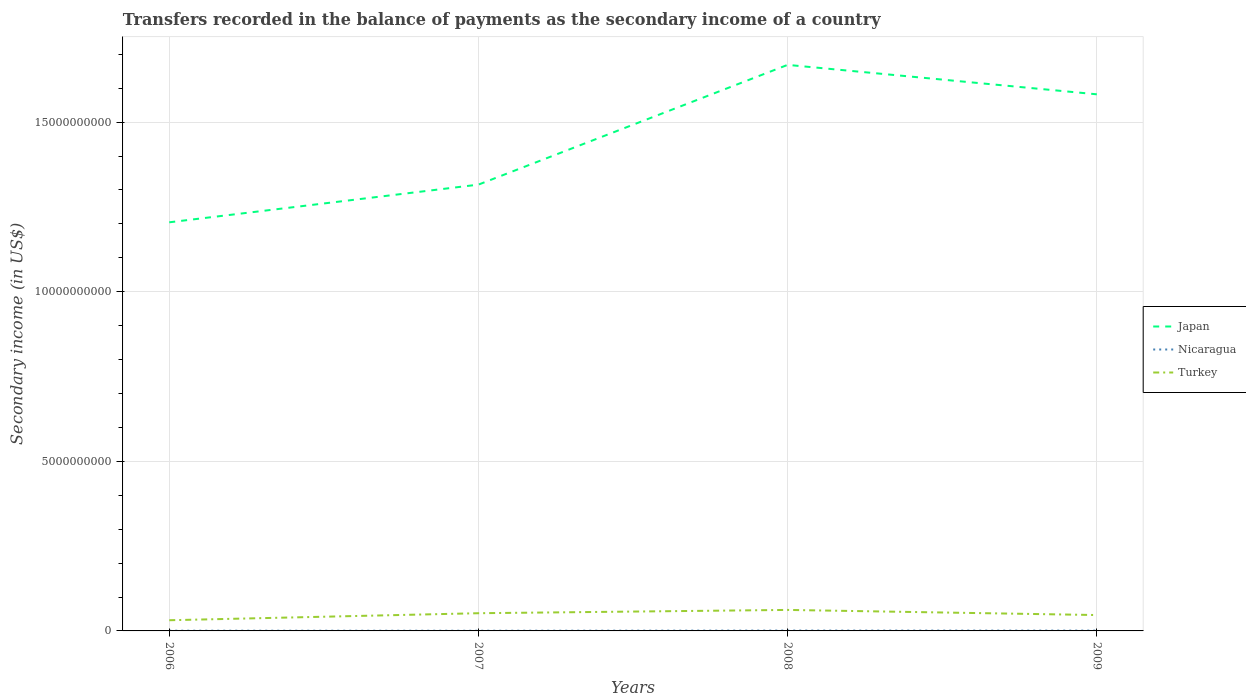Is the number of lines equal to the number of legend labels?
Your answer should be compact. Yes. Across all years, what is the maximum secondary income of in Japan?
Provide a succinct answer. 1.20e+1. In which year was the secondary income of in Nicaragua maximum?
Your answer should be very brief. 2007. What is the total secondary income of in Nicaragua in the graph?
Your answer should be very brief. -4.90e+06. What is the difference between the highest and the second highest secondary income of in Nicaragua?
Make the answer very short. 4.90e+06. Is the secondary income of in Japan strictly greater than the secondary income of in Nicaragua over the years?
Offer a terse response. No. What is the difference between two consecutive major ticks on the Y-axis?
Provide a short and direct response. 5.00e+09. How are the legend labels stacked?
Give a very brief answer. Vertical. What is the title of the graph?
Ensure brevity in your answer.  Transfers recorded in the balance of payments as the secondary income of a country. What is the label or title of the Y-axis?
Provide a short and direct response. Secondary income (in US$). What is the Secondary income (in US$) in Japan in 2006?
Keep it short and to the point. 1.20e+1. What is the Secondary income (in US$) in Nicaragua in 2006?
Offer a terse response. 7.10e+06. What is the Secondary income (in US$) in Turkey in 2006?
Ensure brevity in your answer.  3.15e+08. What is the Secondary income (in US$) in Japan in 2007?
Your answer should be compact. 1.32e+1. What is the Secondary income (in US$) of Nicaragua in 2007?
Keep it short and to the point. 5.60e+06. What is the Secondary income (in US$) of Turkey in 2007?
Keep it short and to the point. 5.22e+08. What is the Secondary income (in US$) of Japan in 2008?
Provide a short and direct response. 1.67e+1. What is the Secondary income (in US$) in Nicaragua in 2008?
Ensure brevity in your answer.  1.05e+07. What is the Secondary income (in US$) of Turkey in 2008?
Offer a terse response. 6.19e+08. What is the Secondary income (in US$) of Japan in 2009?
Make the answer very short. 1.58e+1. What is the Secondary income (in US$) of Nicaragua in 2009?
Give a very brief answer. 9.50e+06. What is the Secondary income (in US$) of Turkey in 2009?
Your answer should be very brief. 4.68e+08. Across all years, what is the maximum Secondary income (in US$) in Japan?
Give a very brief answer. 1.67e+1. Across all years, what is the maximum Secondary income (in US$) in Nicaragua?
Give a very brief answer. 1.05e+07. Across all years, what is the maximum Secondary income (in US$) of Turkey?
Offer a terse response. 6.19e+08. Across all years, what is the minimum Secondary income (in US$) of Japan?
Your response must be concise. 1.20e+1. Across all years, what is the minimum Secondary income (in US$) of Nicaragua?
Your answer should be compact. 5.60e+06. Across all years, what is the minimum Secondary income (in US$) in Turkey?
Offer a very short reply. 3.15e+08. What is the total Secondary income (in US$) of Japan in the graph?
Give a very brief answer. 5.77e+1. What is the total Secondary income (in US$) of Nicaragua in the graph?
Your response must be concise. 3.27e+07. What is the total Secondary income (in US$) in Turkey in the graph?
Keep it short and to the point. 1.92e+09. What is the difference between the Secondary income (in US$) of Japan in 2006 and that in 2007?
Your answer should be very brief. -1.11e+09. What is the difference between the Secondary income (in US$) of Nicaragua in 2006 and that in 2007?
Your response must be concise. 1.50e+06. What is the difference between the Secondary income (in US$) of Turkey in 2006 and that in 2007?
Your answer should be compact. -2.07e+08. What is the difference between the Secondary income (in US$) in Japan in 2006 and that in 2008?
Offer a very short reply. -4.64e+09. What is the difference between the Secondary income (in US$) in Nicaragua in 2006 and that in 2008?
Your answer should be compact. -3.40e+06. What is the difference between the Secondary income (in US$) of Turkey in 2006 and that in 2008?
Give a very brief answer. -3.04e+08. What is the difference between the Secondary income (in US$) in Japan in 2006 and that in 2009?
Your answer should be very brief. -3.77e+09. What is the difference between the Secondary income (in US$) of Nicaragua in 2006 and that in 2009?
Your answer should be compact. -2.40e+06. What is the difference between the Secondary income (in US$) in Turkey in 2006 and that in 2009?
Ensure brevity in your answer.  -1.53e+08. What is the difference between the Secondary income (in US$) in Japan in 2007 and that in 2008?
Offer a very short reply. -3.53e+09. What is the difference between the Secondary income (in US$) of Nicaragua in 2007 and that in 2008?
Give a very brief answer. -4.90e+06. What is the difference between the Secondary income (in US$) of Turkey in 2007 and that in 2008?
Your answer should be compact. -9.70e+07. What is the difference between the Secondary income (in US$) in Japan in 2007 and that in 2009?
Your answer should be very brief. -2.66e+09. What is the difference between the Secondary income (in US$) in Nicaragua in 2007 and that in 2009?
Keep it short and to the point. -3.90e+06. What is the difference between the Secondary income (in US$) in Turkey in 2007 and that in 2009?
Your answer should be compact. 5.40e+07. What is the difference between the Secondary income (in US$) in Japan in 2008 and that in 2009?
Ensure brevity in your answer.  8.68e+08. What is the difference between the Secondary income (in US$) of Turkey in 2008 and that in 2009?
Make the answer very short. 1.51e+08. What is the difference between the Secondary income (in US$) of Japan in 2006 and the Secondary income (in US$) of Nicaragua in 2007?
Your answer should be very brief. 1.20e+1. What is the difference between the Secondary income (in US$) in Japan in 2006 and the Secondary income (in US$) in Turkey in 2007?
Your answer should be compact. 1.15e+1. What is the difference between the Secondary income (in US$) of Nicaragua in 2006 and the Secondary income (in US$) of Turkey in 2007?
Provide a succinct answer. -5.15e+08. What is the difference between the Secondary income (in US$) in Japan in 2006 and the Secondary income (in US$) in Nicaragua in 2008?
Your response must be concise. 1.20e+1. What is the difference between the Secondary income (in US$) in Japan in 2006 and the Secondary income (in US$) in Turkey in 2008?
Keep it short and to the point. 1.14e+1. What is the difference between the Secondary income (in US$) in Nicaragua in 2006 and the Secondary income (in US$) in Turkey in 2008?
Give a very brief answer. -6.12e+08. What is the difference between the Secondary income (in US$) in Japan in 2006 and the Secondary income (in US$) in Nicaragua in 2009?
Offer a very short reply. 1.20e+1. What is the difference between the Secondary income (in US$) of Japan in 2006 and the Secondary income (in US$) of Turkey in 2009?
Ensure brevity in your answer.  1.16e+1. What is the difference between the Secondary income (in US$) of Nicaragua in 2006 and the Secondary income (in US$) of Turkey in 2009?
Ensure brevity in your answer.  -4.61e+08. What is the difference between the Secondary income (in US$) in Japan in 2007 and the Secondary income (in US$) in Nicaragua in 2008?
Keep it short and to the point. 1.31e+1. What is the difference between the Secondary income (in US$) in Japan in 2007 and the Secondary income (in US$) in Turkey in 2008?
Give a very brief answer. 1.25e+1. What is the difference between the Secondary income (in US$) of Nicaragua in 2007 and the Secondary income (in US$) of Turkey in 2008?
Give a very brief answer. -6.13e+08. What is the difference between the Secondary income (in US$) in Japan in 2007 and the Secondary income (in US$) in Nicaragua in 2009?
Your answer should be very brief. 1.31e+1. What is the difference between the Secondary income (in US$) of Japan in 2007 and the Secondary income (in US$) of Turkey in 2009?
Make the answer very short. 1.27e+1. What is the difference between the Secondary income (in US$) of Nicaragua in 2007 and the Secondary income (in US$) of Turkey in 2009?
Your answer should be compact. -4.62e+08. What is the difference between the Secondary income (in US$) of Japan in 2008 and the Secondary income (in US$) of Nicaragua in 2009?
Offer a very short reply. 1.67e+1. What is the difference between the Secondary income (in US$) in Japan in 2008 and the Secondary income (in US$) in Turkey in 2009?
Your response must be concise. 1.62e+1. What is the difference between the Secondary income (in US$) in Nicaragua in 2008 and the Secondary income (in US$) in Turkey in 2009?
Your answer should be very brief. -4.58e+08. What is the average Secondary income (in US$) in Japan per year?
Make the answer very short. 1.44e+1. What is the average Secondary income (in US$) of Nicaragua per year?
Provide a short and direct response. 8.18e+06. What is the average Secondary income (in US$) of Turkey per year?
Make the answer very short. 4.81e+08. In the year 2006, what is the difference between the Secondary income (in US$) of Japan and Secondary income (in US$) of Nicaragua?
Offer a very short reply. 1.20e+1. In the year 2006, what is the difference between the Secondary income (in US$) of Japan and Secondary income (in US$) of Turkey?
Your response must be concise. 1.17e+1. In the year 2006, what is the difference between the Secondary income (in US$) in Nicaragua and Secondary income (in US$) in Turkey?
Give a very brief answer. -3.08e+08. In the year 2007, what is the difference between the Secondary income (in US$) in Japan and Secondary income (in US$) in Nicaragua?
Keep it short and to the point. 1.32e+1. In the year 2007, what is the difference between the Secondary income (in US$) of Japan and Secondary income (in US$) of Turkey?
Offer a very short reply. 1.26e+1. In the year 2007, what is the difference between the Secondary income (in US$) of Nicaragua and Secondary income (in US$) of Turkey?
Your response must be concise. -5.16e+08. In the year 2008, what is the difference between the Secondary income (in US$) of Japan and Secondary income (in US$) of Nicaragua?
Make the answer very short. 1.67e+1. In the year 2008, what is the difference between the Secondary income (in US$) in Japan and Secondary income (in US$) in Turkey?
Give a very brief answer. 1.61e+1. In the year 2008, what is the difference between the Secondary income (in US$) of Nicaragua and Secondary income (in US$) of Turkey?
Ensure brevity in your answer.  -6.08e+08. In the year 2009, what is the difference between the Secondary income (in US$) of Japan and Secondary income (in US$) of Nicaragua?
Make the answer very short. 1.58e+1. In the year 2009, what is the difference between the Secondary income (in US$) of Japan and Secondary income (in US$) of Turkey?
Keep it short and to the point. 1.54e+1. In the year 2009, what is the difference between the Secondary income (in US$) in Nicaragua and Secondary income (in US$) in Turkey?
Offer a terse response. -4.58e+08. What is the ratio of the Secondary income (in US$) of Japan in 2006 to that in 2007?
Provide a succinct answer. 0.92. What is the ratio of the Secondary income (in US$) of Nicaragua in 2006 to that in 2007?
Give a very brief answer. 1.27. What is the ratio of the Secondary income (in US$) of Turkey in 2006 to that in 2007?
Give a very brief answer. 0.6. What is the ratio of the Secondary income (in US$) of Japan in 2006 to that in 2008?
Provide a short and direct response. 0.72. What is the ratio of the Secondary income (in US$) in Nicaragua in 2006 to that in 2008?
Ensure brevity in your answer.  0.68. What is the ratio of the Secondary income (in US$) in Turkey in 2006 to that in 2008?
Offer a terse response. 0.51. What is the ratio of the Secondary income (in US$) in Japan in 2006 to that in 2009?
Your answer should be compact. 0.76. What is the ratio of the Secondary income (in US$) in Nicaragua in 2006 to that in 2009?
Your response must be concise. 0.75. What is the ratio of the Secondary income (in US$) in Turkey in 2006 to that in 2009?
Your answer should be compact. 0.67. What is the ratio of the Secondary income (in US$) of Japan in 2007 to that in 2008?
Make the answer very short. 0.79. What is the ratio of the Secondary income (in US$) in Nicaragua in 2007 to that in 2008?
Make the answer very short. 0.53. What is the ratio of the Secondary income (in US$) in Turkey in 2007 to that in 2008?
Make the answer very short. 0.84. What is the ratio of the Secondary income (in US$) in Japan in 2007 to that in 2009?
Provide a short and direct response. 0.83. What is the ratio of the Secondary income (in US$) of Nicaragua in 2007 to that in 2009?
Provide a succinct answer. 0.59. What is the ratio of the Secondary income (in US$) in Turkey in 2007 to that in 2009?
Your answer should be very brief. 1.12. What is the ratio of the Secondary income (in US$) of Japan in 2008 to that in 2009?
Your answer should be very brief. 1.05. What is the ratio of the Secondary income (in US$) in Nicaragua in 2008 to that in 2009?
Keep it short and to the point. 1.11. What is the ratio of the Secondary income (in US$) of Turkey in 2008 to that in 2009?
Give a very brief answer. 1.32. What is the difference between the highest and the second highest Secondary income (in US$) in Japan?
Offer a terse response. 8.68e+08. What is the difference between the highest and the second highest Secondary income (in US$) of Nicaragua?
Make the answer very short. 1.00e+06. What is the difference between the highest and the second highest Secondary income (in US$) of Turkey?
Keep it short and to the point. 9.70e+07. What is the difference between the highest and the lowest Secondary income (in US$) of Japan?
Your answer should be very brief. 4.64e+09. What is the difference between the highest and the lowest Secondary income (in US$) in Nicaragua?
Offer a terse response. 4.90e+06. What is the difference between the highest and the lowest Secondary income (in US$) of Turkey?
Offer a very short reply. 3.04e+08. 